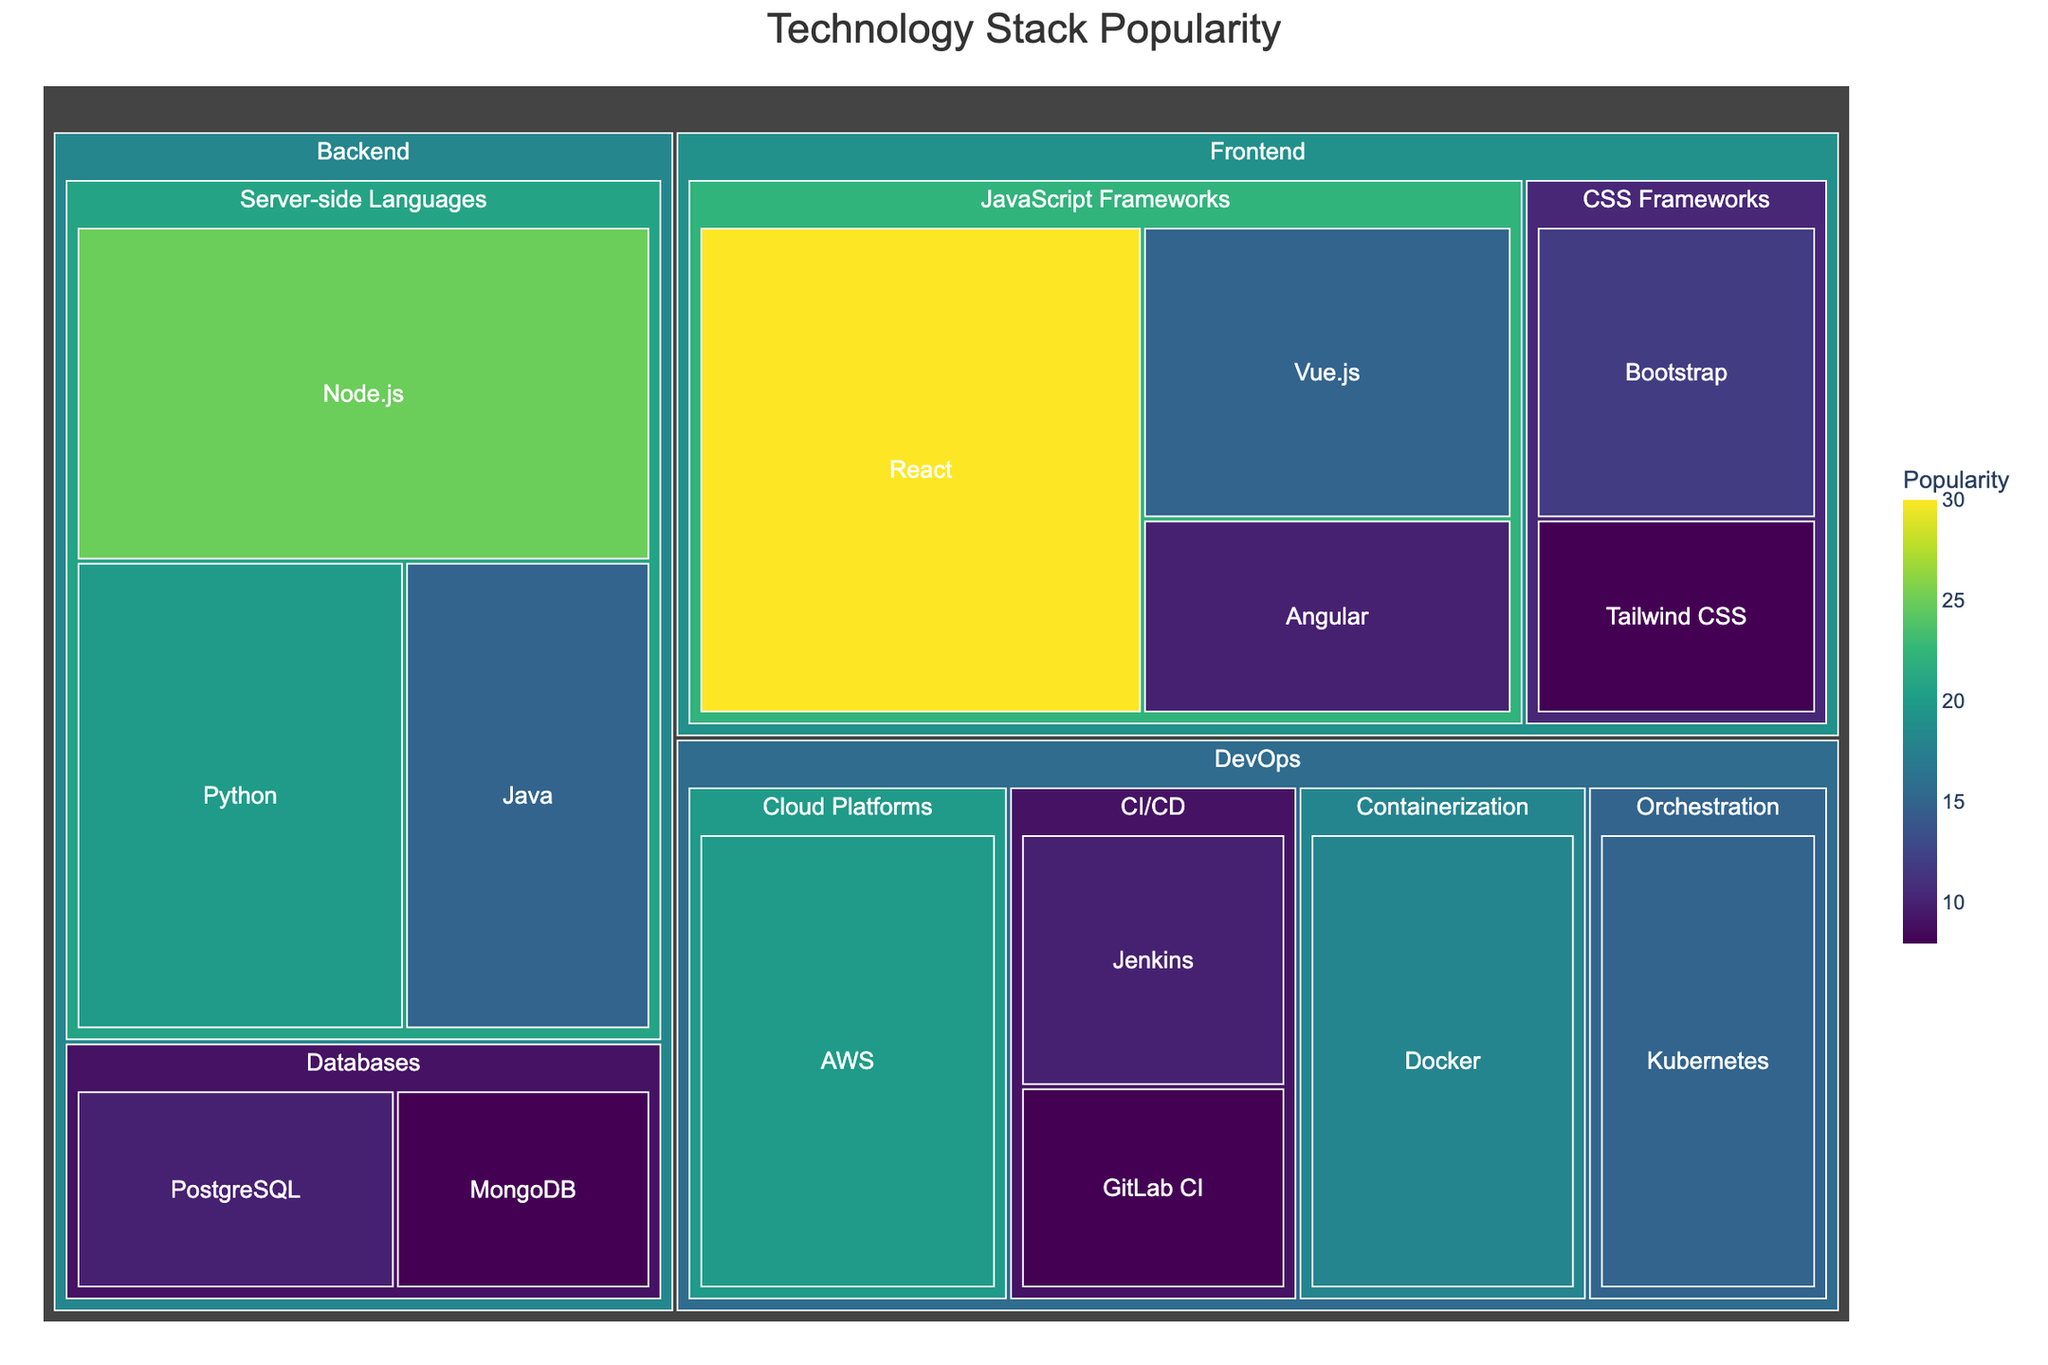What's the most popular technology stack in the Frontend category? To find the most popular technology stack in the Frontend category, identify the subtree labeled 'Frontend' and compare the popularity values of its subcategories. The tool with the highest value would be the most popular. React has the highest popularity value of 30 within the subcategory JavaScript Frameworks.
Answer: React Which technology stack has a higher popularity, Node.js or Python within the Backend category? Both Node.js and Python belong to the subcategory Server-side Languages under Backend. Compare their popularity values. Node.js has a popularity of 25, and Python has 20. Thus, Node.js is more popular than Python.
Answer: Node.js What is the combined popularity of Kubernetes and Docker in the DevOps category? To get the combined popularity, find the popularity values of Kubernetes and Docker in the DevOps category. Kubernetes has a value of 15, and Docker has a value of 18. Adding them gives 15 + 18 = 33.
Answer: 33 What percentage of the total popularity does React occupy in the Frontend category? Compute React’s percentage in the Frontend category by dividing React's popularity by the total popularity of all Frontend tools. The total Frontend popularity is 30 (React) + 15 (Vue.js) + 10 (Angular) + 12 (Bootstrap) + 8 (Tailwind CSS) = 75. The percentage for React is (30/75) * 100% ≈ 40%.
Answer: 40% Between Jenkins and GitLab CI in the DevOps category, which has higher popularity and by how much? Compare the popularity values of Jenkins and GitLab CI within the DevOps category. Jenkins has a value of 10, and GitLab CI has 8. The difference is 10 - 8 = 2.
Answer: Jenkins, by 2 What is the least popular technology stack in the Backend category? Identify the technology stack in the Backend category with the lowest popularity value. MongoDB has the lowest value of 8 among Backend tools (PostgreSQL with 10, Node.js with 25, Python with 20, Java with 15).
Answer: MongoDB How does the popularity of Bootstrap compare to Tailwind CSS in the Frontend category? Compare the popularity values of Bootstrap and Tailwind CSS within the Frontend category. Bootstrap has a popularity of 12, while Tailwind CSS has 8. Therefore, Bootstrap is more popular than Tailwind CSS.
Answer: Bootstrap What is the total popularity of all tools within the DevOps category? Sum the popularity values of all tools in the DevOps category. The values are 18 (Docker) + 15 (Kubernetes) + 10 (Jenkins) + 8 (GitLab CI) + 20 (AWS) = 71.
Answer: 71 What tool has the highest popularity in the DevOps category? Look at all the tools listed under the DevOps category and identify the one with the highest popularity value. AWS has the highest popularity at 20.
Answer: AWS In the Backend category, how does the combined popularity of Server-side Languages compare to Databases? Calculate the combined popularity for each subcategory within Backend. Server-side Languages (Node.js with 25 + Python with 20 + Java with 15) equals 60, and Databases (PostgreSQL with 10 + MongoDB with 8) equals 18. Server-side Languages are significantly more popular than Databases at 60 compared to 18.
Answer: Server-side Languages are more popular 